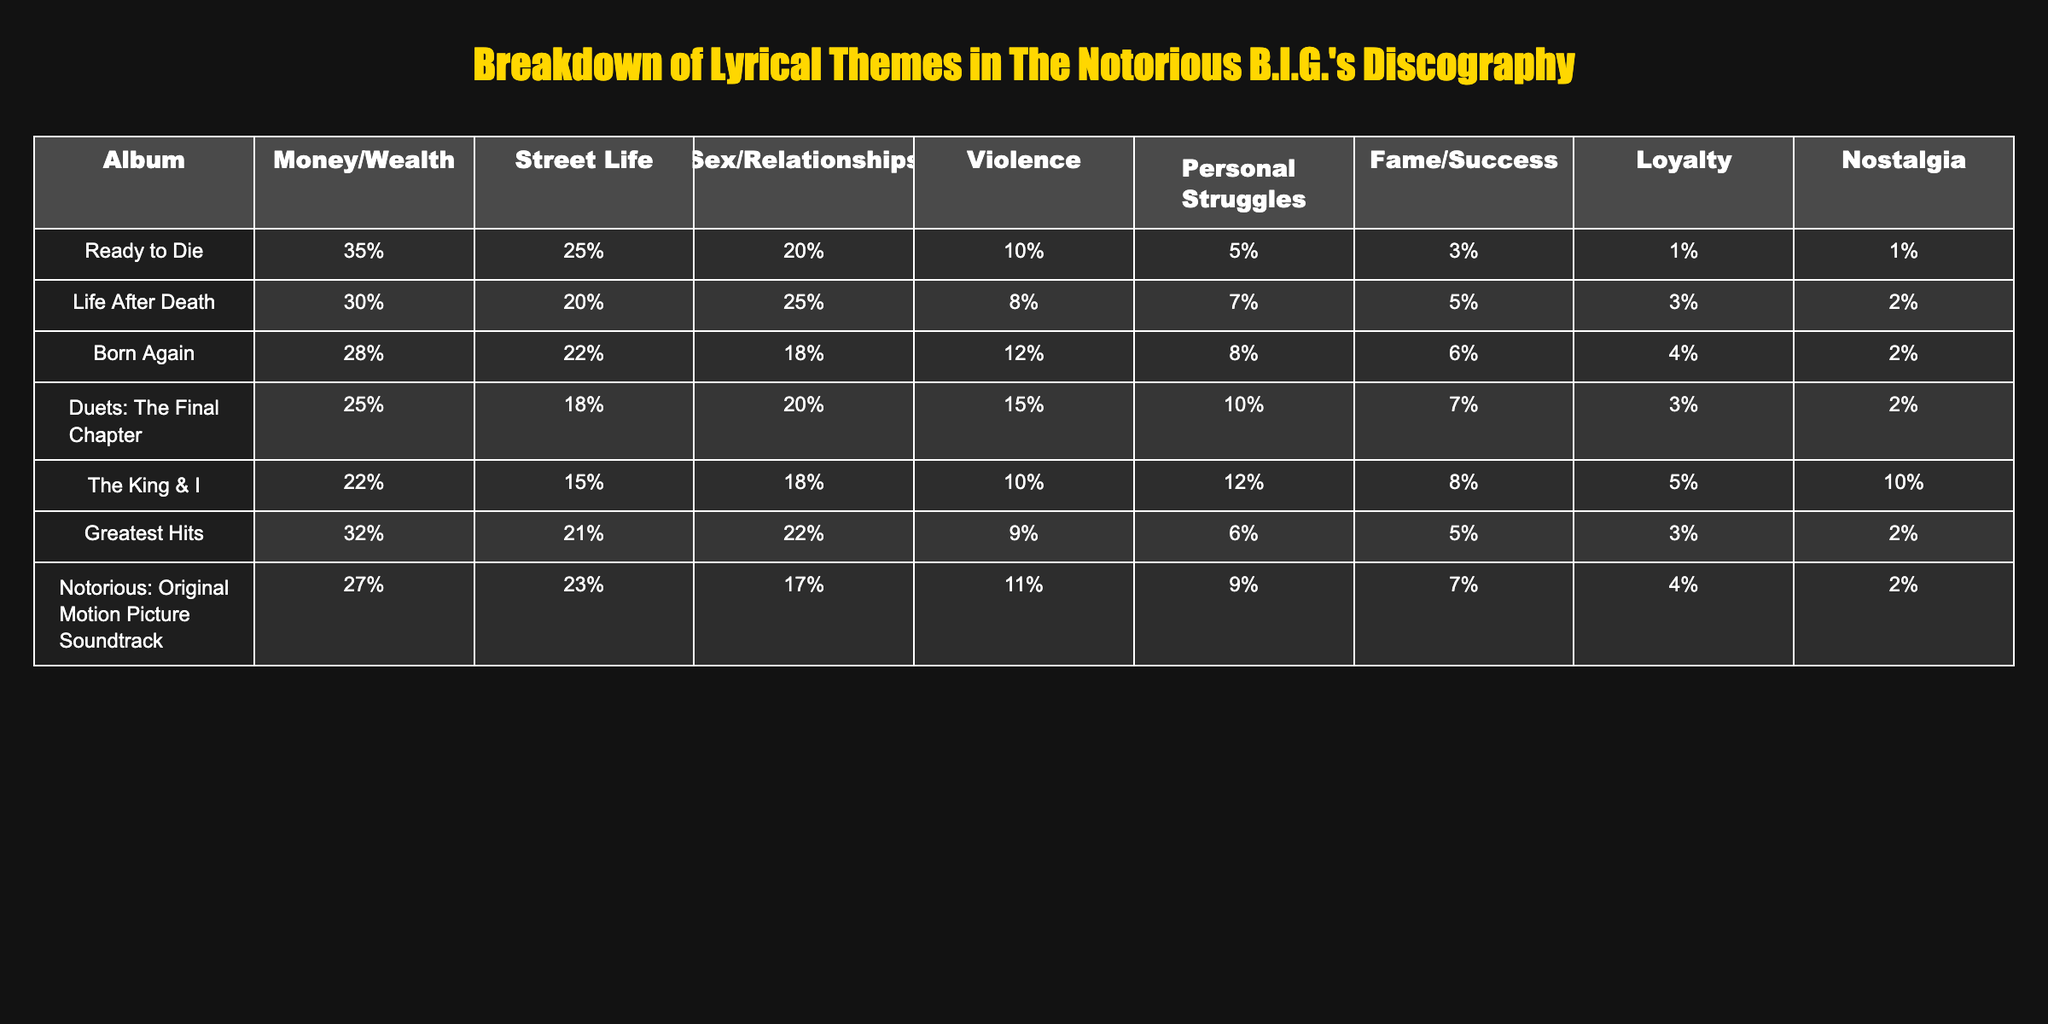What lyrical theme has the highest percentage in the album "Ready to Die"? In the table, the column for "Ready to Die" shows that the theme "Money/Wealth" has a percentage of 35%, which is the highest value in that row.
Answer: Money/Wealth Which album has the lowest percentage for the theme "Fame/Success"? The table indicates that "The King & I" has a percentage of 5% for the theme "Fame/Success", which is the lowest value in that column.
Answer: The King & I What is the total percentage of the "Street Life" theme in all albums combined? To find the total percentage for "Street Life", we sum the percentages across all albums: 25% + 20% + 22% + 18% + 15% + 21% + 23% = 144%.
Answer: 144% In how many albums does the theme "Sex/Relationships" account for more than 20%? By reviewing the table, the "Sex/Relationships" theme is above 20% in two albums: "Life After Death" (25%) and "Greatest Hits" (22%).
Answer: 2 Which album shows the largest difference between "Money/Wealth" and "Violence" percentages? Calculating the difference for each album: "Ready to Die" = 35%-10% = 25, "Life After Death" = 30%-8% = 22, "Born Again" = 28%-12% = 16, "Duets" = 25%-15% = 10, "The King & I" = 22%-10% = 12, "Greatest Hits" = 32%-9% = 23, "Soundtrack" = 27%-11% = 16. The largest difference is from "Ready to Die".
Answer: Ready to Die Does the theme "Nostalgia" appear in any album with a percentage greater than 5%? By examining the table, "The King & I" has a percentage of 10% for "Nostalgia", which is indeed greater than 5%.
Answer: Yes What is the average percentage of "Personal Struggles" across all albums? The percentages for "Personal Struggles" are 5%, 7%, 8%, 10%, 12%, 6%, and 9%. Adding these gives 57%, and dividing by 7 (the number of albums) provides an average of 57% / 7 = 8.14%.
Answer: 8.14% Which lyrical theme has maintained the highest average across all albums? To determine this, we compute the average of each theme's percentages: Money/Wealth = (35+30+28+25+22+32+27)/7 = 27.29%; Street Life = (25+20+22+18+15+21+23)/7 = 20.14%; counting for all shows 'Money/Wealth' highest.
Answer: Money/Wealth Which album has the closest percentages for "Loyalty" and "Nostalgia"? Reviewing the table, "Born Again" shows percentages of 4% for "Loyalty" and 2% for "Nostalgia", making it the closest pair in terms of values.
Answer: Born Again 